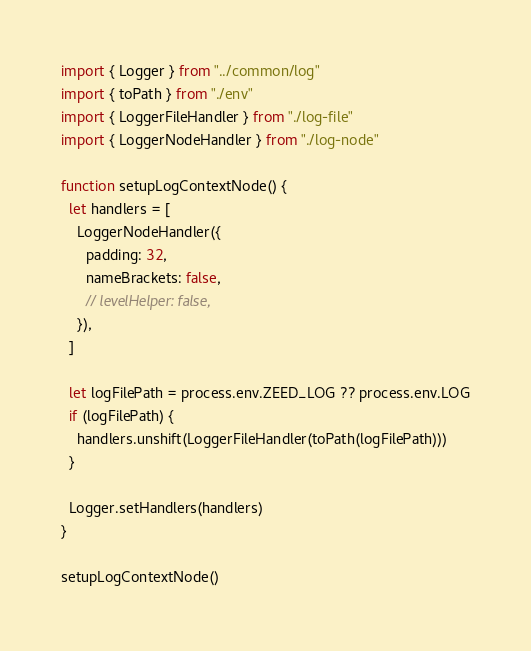Convert code to text. <code><loc_0><loc_0><loc_500><loc_500><_TypeScript_>import { Logger } from "../common/log"
import { toPath } from "./env"
import { LoggerFileHandler } from "./log-file"
import { LoggerNodeHandler } from "./log-node"

function setupLogContextNode() {
  let handlers = [
    LoggerNodeHandler({
      padding: 32,
      nameBrackets: false,
      // levelHelper: false,
    }),
  ]

  let logFilePath = process.env.ZEED_LOG ?? process.env.LOG
  if (logFilePath) {
    handlers.unshift(LoggerFileHandler(toPath(logFilePath)))
  }

  Logger.setHandlers(handlers)
}

setupLogContextNode()
</code> 